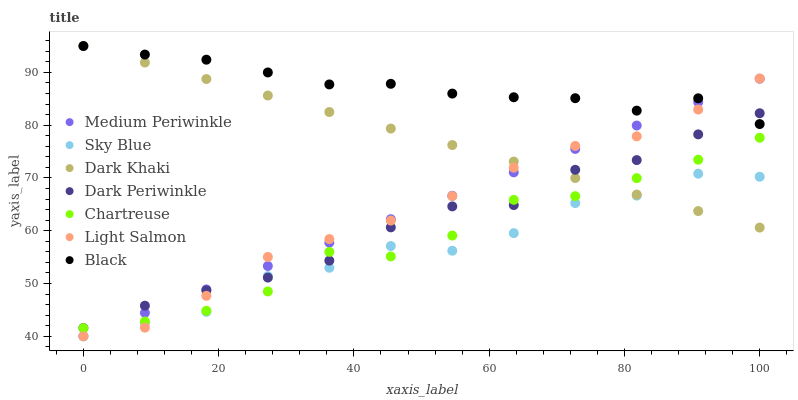Does Sky Blue have the minimum area under the curve?
Answer yes or no. Yes. Does Black have the maximum area under the curve?
Answer yes or no. Yes. Does Medium Periwinkle have the minimum area under the curve?
Answer yes or no. No. Does Medium Periwinkle have the maximum area under the curve?
Answer yes or no. No. Is Dark Khaki the smoothest?
Answer yes or no. Yes. Is Sky Blue the roughest?
Answer yes or no. Yes. Is Medium Periwinkle the smoothest?
Answer yes or no. No. Is Medium Periwinkle the roughest?
Answer yes or no. No. Does Light Salmon have the lowest value?
Answer yes or no. Yes. Does Dark Khaki have the lowest value?
Answer yes or no. No. Does Black have the highest value?
Answer yes or no. Yes. Does Medium Periwinkle have the highest value?
Answer yes or no. No. Is Chartreuse less than Black?
Answer yes or no. Yes. Is Black greater than Chartreuse?
Answer yes or no. Yes. Does Light Salmon intersect Dark Periwinkle?
Answer yes or no. Yes. Is Light Salmon less than Dark Periwinkle?
Answer yes or no. No. Is Light Salmon greater than Dark Periwinkle?
Answer yes or no. No. Does Chartreuse intersect Black?
Answer yes or no. No. 